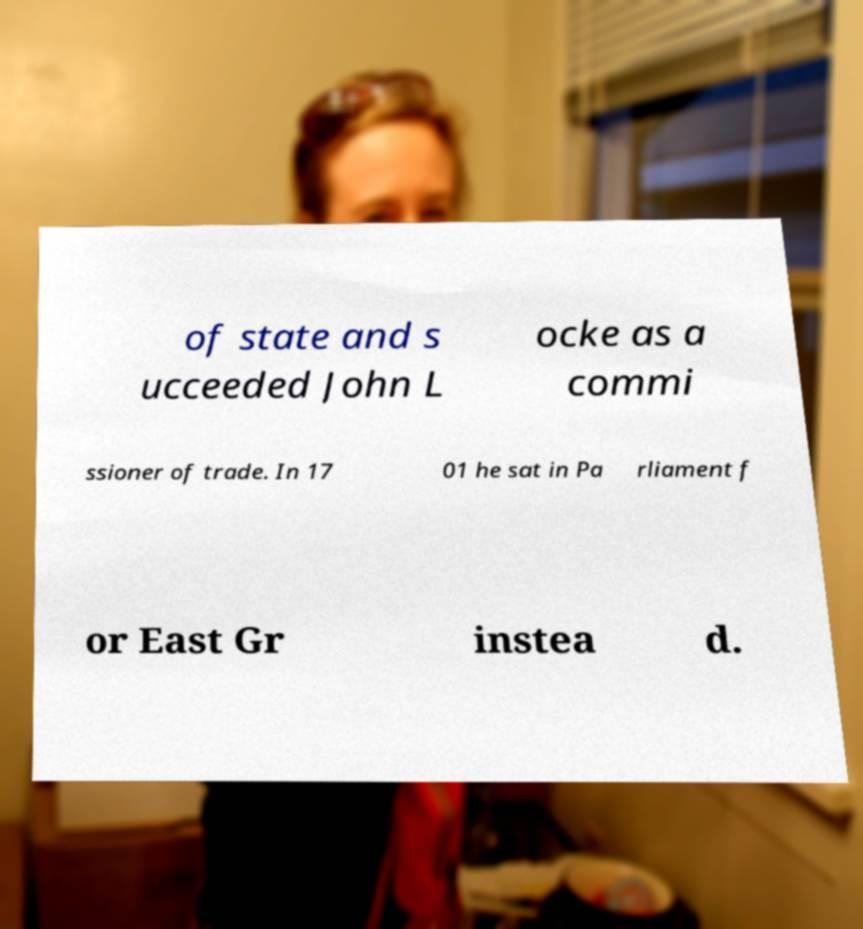What messages or text are displayed in this image? I need them in a readable, typed format. of state and s ucceeded John L ocke as a commi ssioner of trade. In 17 01 he sat in Pa rliament f or East Gr instea d. 